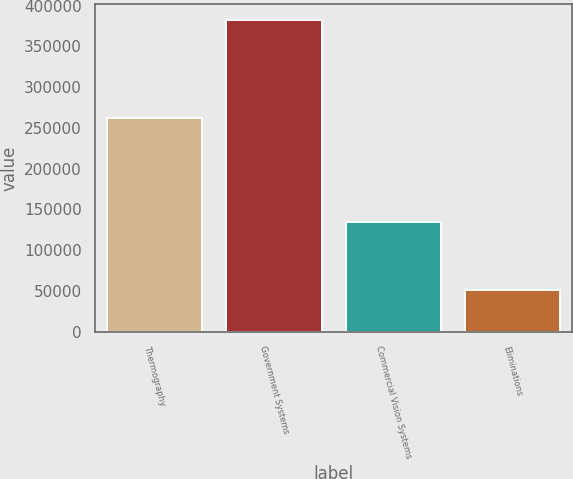<chart> <loc_0><loc_0><loc_500><loc_500><bar_chart><fcel>Thermography<fcel>Government Systems<fcel>Commercial Vision Systems<fcel>Eliminations<nl><fcel>261831<fcel>382347<fcel>135219<fcel>51886<nl></chart> 